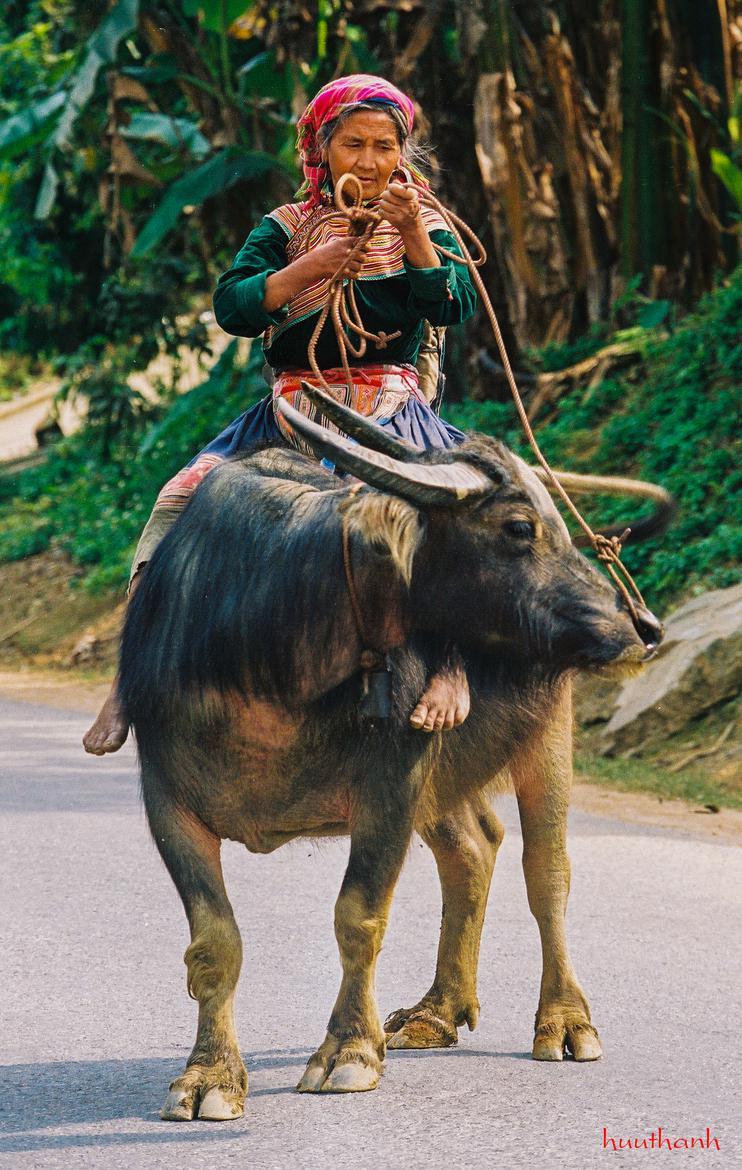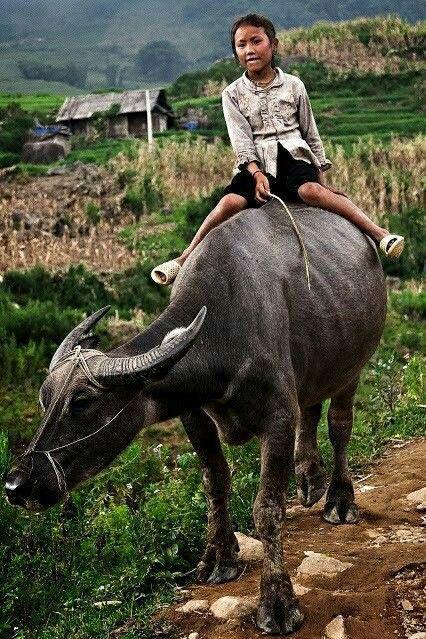The first image is the image on the left, the second image is the image on the right. Assess this claim about the two images: "There are exactly two people riding on animals.". Correct or not? Answer yes or no. Yes. The first image is the image on the left, the second image is the image on the right. Analyze the images presented: Is the assertion "There is exactly one person riding a water buffalo in each image." valid? Answer yes or no. Yes. 